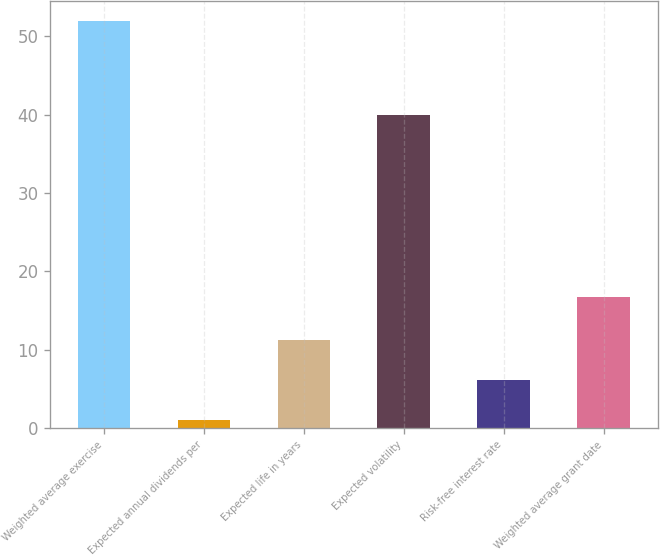Convert chart. <chart><loc_0><loc_0><loc_500><loc_500><bar_chart><fcel>Weighted average exercise<fcel>Expected annual dividends per<fcel>Expected life in years<fcel>Expected volatility<fcel>Risk-free interest rate<fcel>Weighted average grant date<nl><fcel>51.93<fcel>1<fcel>11.18<fcel>40<fcel>6.09<fcel>16.73<nl></chart> 